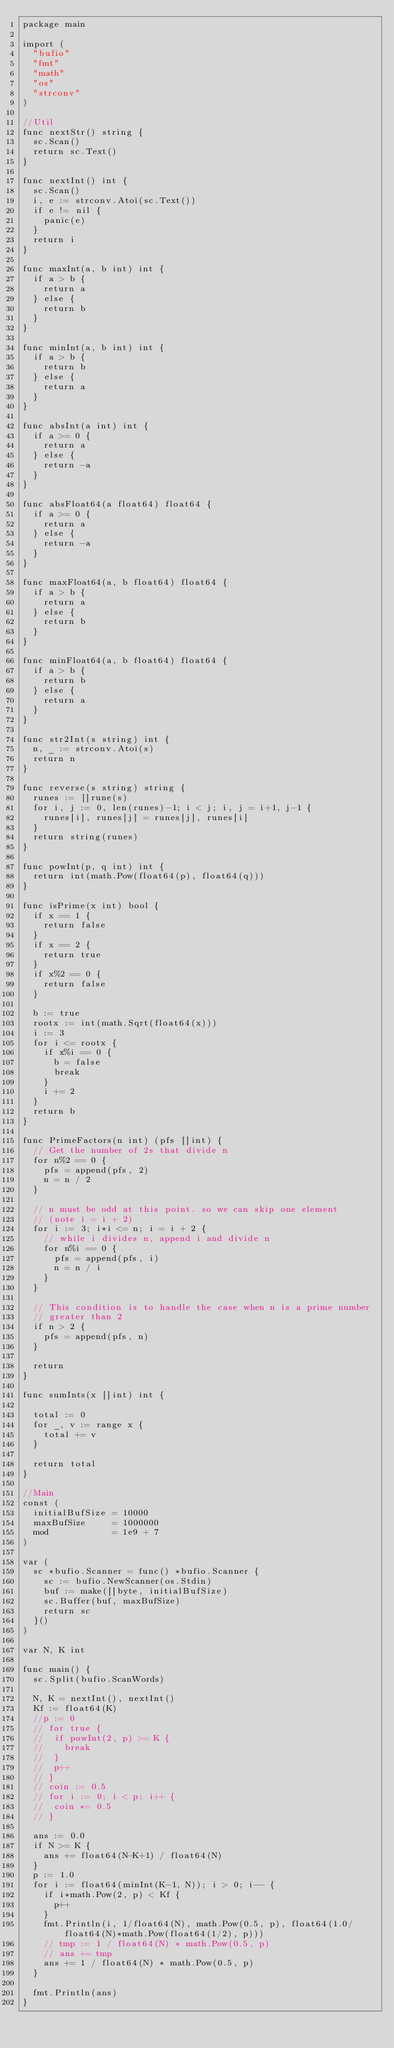<code> <loc_0><loc_0><loc_500><loc_500><_Go_>package main

import (
	"bufio"
	"fmt"
	"math"
	"os"
	"strconv"
)

//Util
func nextStr() string {
	sc.Scan()
	return sc.Text()
}

func nextInt() int {
	sc.Scan()
	i, e := strconv.Atoi(sc.Text())
	if e != nil {
		panic(e)
	}
	return i
}

func maxInt(a, b int) int {
	if a > b {
		return a
	} else {
		return b
	}
}

func minInt(a, b int) int {
	if a > b {
		return b
	} else {
		return a
	}
}

func absInt(a int) int {
	if a >= 0 {
		return a
	} else {
		return -a
	}
}

func absFloat64(a float64) float64 {
	if a >= 0 {
		return a
	} else {
		return -a
	}
}

func maxFloat64(a, b float64) float64 {
	if a > b {
		return a
	} else {
		return b
	}
}

func minFloat64(a, b float64) float64 {
	if a > b {
		return b
	} else {
		return a
	}
}

func str2Int(s string) int {
	n, _ := strconv.Atoi(s)
	return n
}

func reverse(s string) string {
	runes := []rune(s)
	for i, j := 0, len(runes)-1; i < j; i, j = i+1, j-1 {
		runes[i], runes[j] = runes[j], runes[i]
	}
	return string(runes)
}

func powInt(p, q int) int {
	return int(math.Pow(float64(p), float64(q)))
}

func isPrime(x int) bool {
	if x == 1 {
		return false
	}
	if x == 2 {
		return true
	}
	if x%2 == 0 {
		return false
	}

	b := true
	rootx := int(math.Sqrt(float64(x)))
	i := 3
	for i <= rootx {
		if x%i == 0 {
			b = false
			break
		}
		i += 2
	}
	return b
}

func PrimeFactors(n int) (pfs []int) {
	// Get the number of 2s that divide n
	for n%2 == 0 {
		pfs = append(pfs, 2)
		n = n / 2
	}

	// n must be odd at this point. so we can skip one element
	// (note i = i + 2)
	for i := 3; i*i <= n; i = i + 2 {
		// while i divides n, append i and divide n
		for n%i == 0 {
			pfs = append(pfs, i)
			n = n / i
		}
	}

	// This condition is to handle the case when n is a prime number
	// greater than 2
	if n > 2 {
		pfs = append(pfs, n)
	}

	return
}

func sumInts(x []int) int {

	total := 0
	for _, v := range x {
		total += v
	}

	return total
}

//Main
const (
	initialBufSize = 10000
	maxBufSize     = 1000000
	mod            = 1e9 + 7
)

var (
	sc *bufio.Scanner = func() *bufio.Scanner {
		sc := bufio.NewScanner(os.Stdin)
		buf := make([]byte, initialBufSize)
		sc.Buffer(buf, maxBufSize)
		return sc
	}()
)

var N, K int

func main() {
	sc.Split(bufio.ScanWords)

	N, K = nextInt(), nextInt()
	Kf := float64(K)
	//p := 0
	// for true {
	// 	if powInt(2, p) >= K {
	// 		break
	// 	}
	// 	p++
	// }
	// coin := 0.5
	// for i := 0; i < p; i++ {
	// 	coin *= 0.5
	// }

	ans := 0.0
	if N >= K {
		ans += float64(N-K+1) / float64(N)
	}
	p := 1.0
	for i := float64(minInt(K-1, N)); i > 0; i-- {
		if i*math.Pow(2, p) < Kf {
			p++
		}
		fmt.Println(i, 1/float64(N), math.Pow(0.5, p), float64(1.0/float64(N)*math.Pow(float64(1/2), p)))
		// tmp := 1 / float64(N) * math.Pow(0.5, p)
		// ans += tmp
		ans += 1 / float64(N) * math.Pow(0.5, p)
	}

	fmt.Println(ans)
}
</code> 